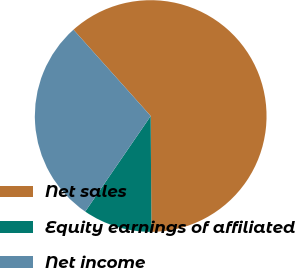Convert chart to OTSL. <chart><loc_0><loc_0><loc_500><loc_500><pie_chart><fcel>Net sales<fcel>Equity earnings of affiliated<fcel>Net income<nl><fcel>61.51%<fcel>9.66%<fcel>28.82%<nl></chart> 